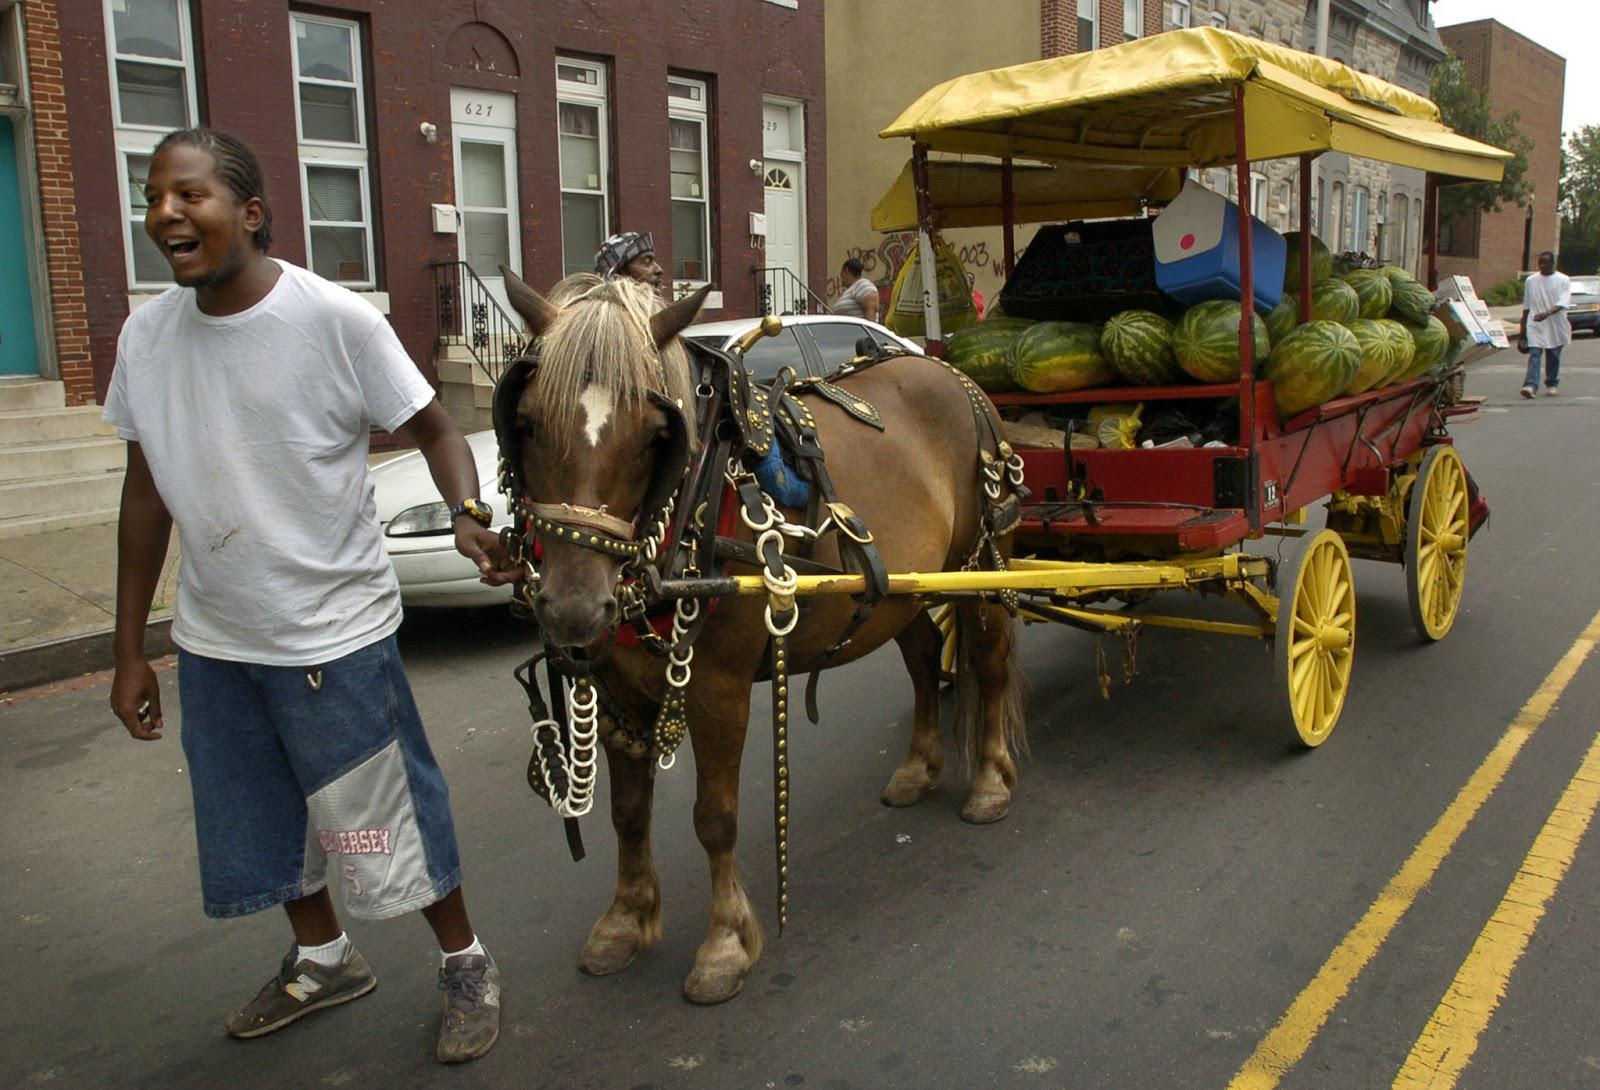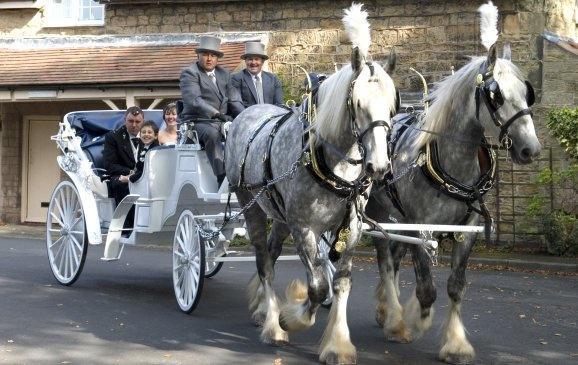The first image is the image on the left, the second image is the image on the right. For the images displayed, is the sentence "Teams of two horses are pulling the carriages." factually correct? Answer yes or no. Yes. The first image is the image on the left, the second image is the image on the right. Evaluate the accuracy of this statement regarding the images: "An image shows a four-wheeled wagon pulled by more than one horse.". Is it true? Answer yes or no. Yes. 